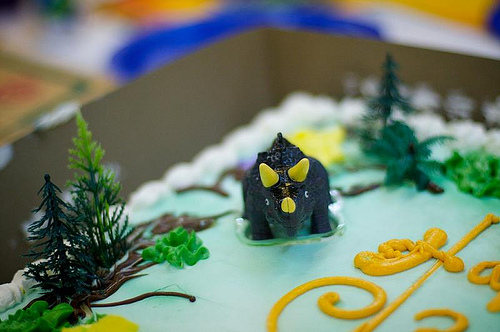<image>
Is the dinosaur on the cake? Yes. Looking at the image, I can see the dinosaur is positioned on top of the cake, with the cake providing support. 